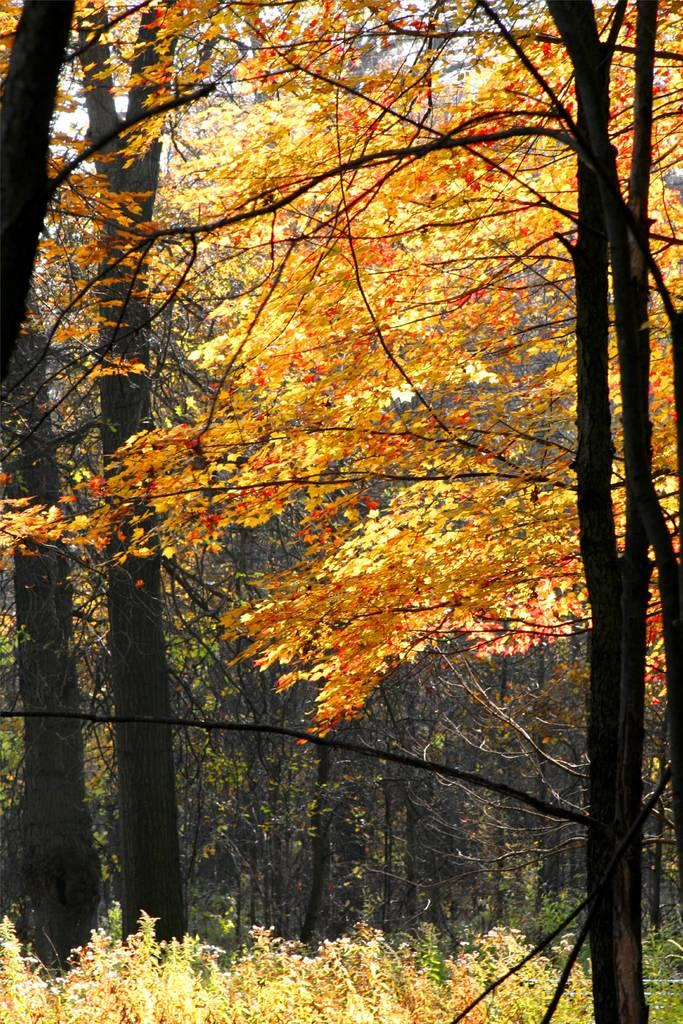What type of vegetation can be seen in the image? There are tall trees and small plants in the image. Can you describe the size of the trees in the image? The trees in the image are tall. What other types of plants are present in the image? There are small plants in the image. What kind of pets can be seen playing with the plastic apparatus in the image? There are no pets or plastic apparatus present in the image; it only features tall trees and small plants. 